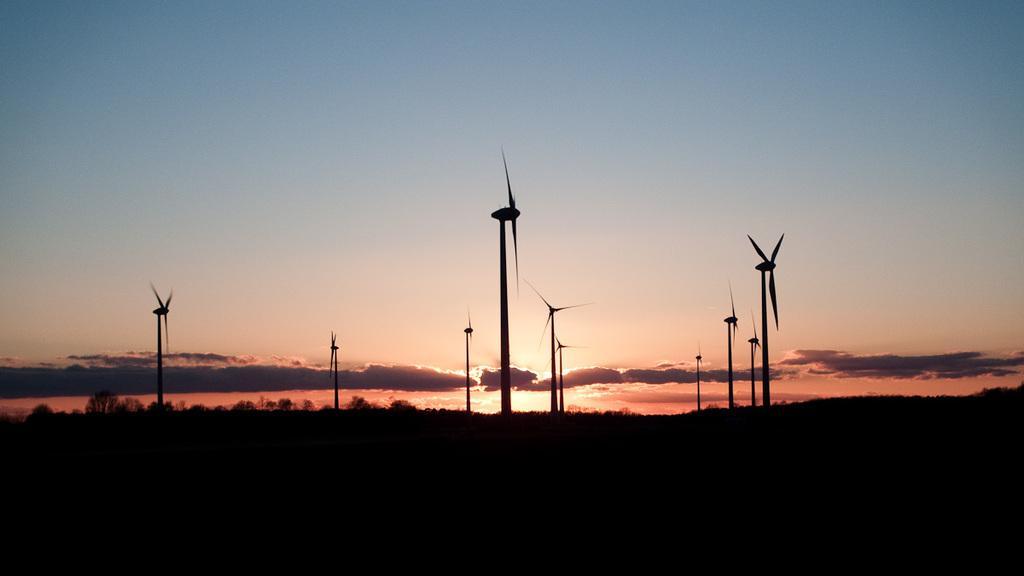In one or two sentences, can you explain what this image depicts? In this image we can see windmills, trees and sky with clouds. 